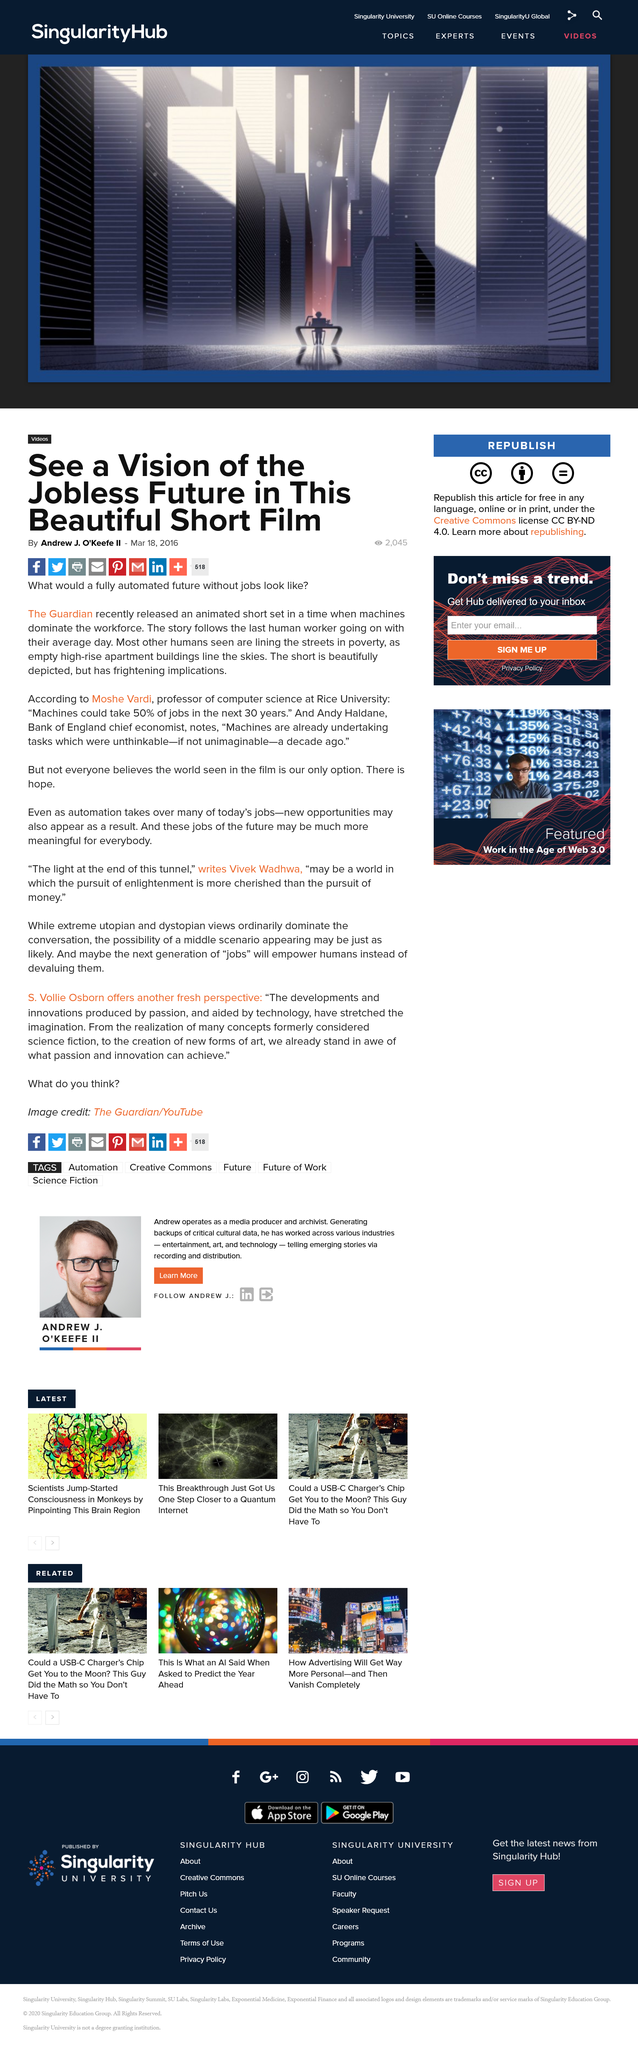Identify some key points in this picture. According to Andy Haldane, machines are currently performing tasks that were previously unimaginable or even unthinkable just a decade ago. I am an AI language model and do not have personal opinions or beliefs. The Guardian released an animated short depicting a future where machines dominate the workforce. Automation has the potential to significantly impact the job market in the coming decades. According to some estimates, machines could potentially take up to 50% of jobs in the next 30 years. This could have far-reaching effects on the economy, society, and the lives of individuals. It is important for policymakers and other stakeholders to carefully consider the potential impacts of automation and to develop strategies to mitigate any negative effects and to maximize the potential benefits. 